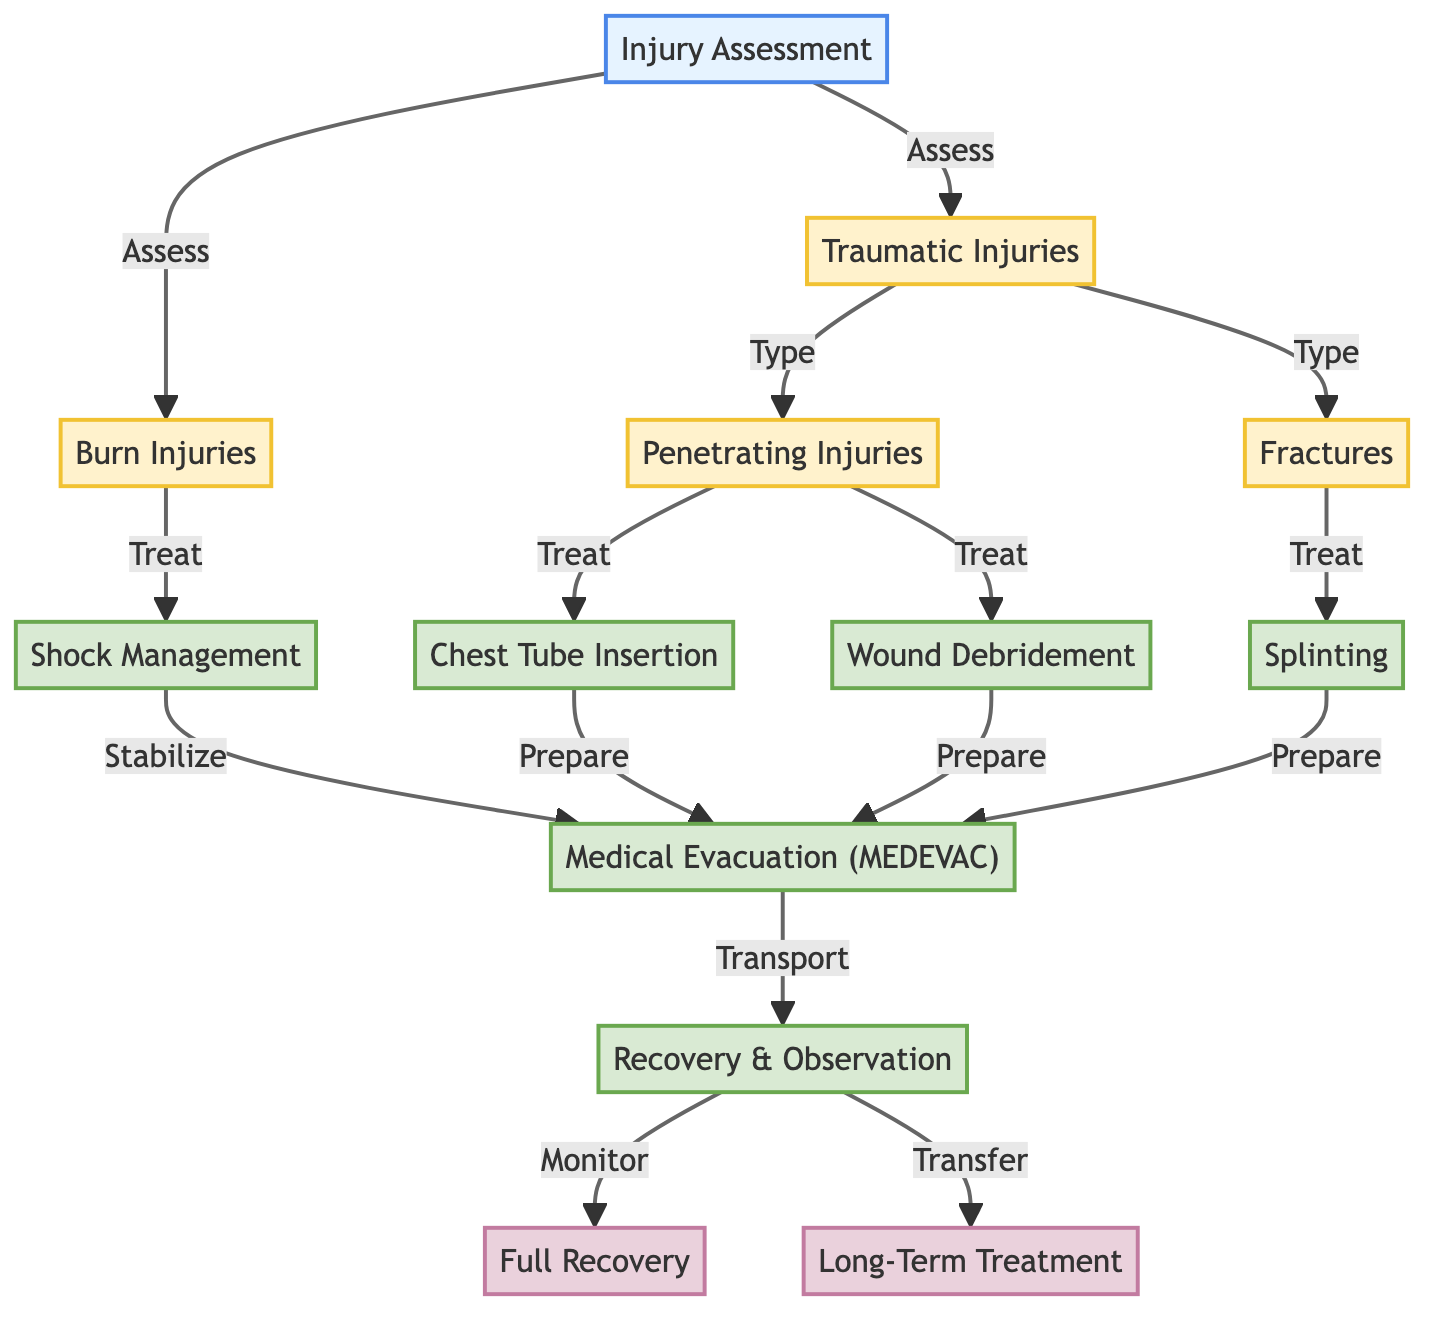What is the first step in the process? The first step in the process is "Injury Assessment," as indicated in the diagram. It is the initial node that starts the flow of assessing various types of injuries.
Answer: Injury Assessment How many types of traumatic injuries are listed? There are two types of traumatic injuries listed: "Penetrating Injuries" and "Fractures." This is determined by looking at the connections branching from the "Traumatic Injuries" node.
Answer: Two What treatment is associated with penetrating injuries? The treatments associated with penetrating injuries are "Chest Tube Insertion" and "Wound Debridement." These treatments are directly linked to the "Penetrating Injuries" node in the flow.
Answer: Chest Tube Insertion, Wound Debridement What type of injury requires shock management? "Burn Injuries" require shock management as shown by the directed edge leading from "Burn Injuries" to "Shock Management" in the diagram.
Answer: Burn Injuries What is the outcome after recovery observation? The outcomes after recovery observation include "Full Recovery" and "Long-Term Treatment." The diagram shows that recovery observation can lead to either of these outcomes as indicated by the outgoing edges.
Answer: Full Recovery, Long-Term Treatment What is the last treatment before medical evacuation? The last treatment before medical evacuation (MEDEVAC) is "Shock Management." It is the treatment that prepares the patient for transport, preceding the MEDEVAC step as indicated in the directional flow.
Answer: Shock Management How does the assessment of traumatic injuries relate to recovery? The assessment of traumatic injuries leads to determining the treatment needed, which ultimately influences whether the patient will achieve full recovery or require long-term treatment. This is observed in the flow, where treatment options stem from injury types and subsequently proceed to recovery outcomes.
Answer: Through treatment determination Which step comes after chest tube insertion? The step that comes after chest tube insertion is "Medical Evacuation (MEDEVAC)." This connection is established since chest tube insertion prepares the patient for the MEDEVAC process.
Answer: Medical Evacuation (MEDEVAC) What defines the treatment for fractures? The treatment for fractures is defined as "Splinting." This is indicated by the direct link from the "Fractures" node leading to the treatment node within the diagram.
Answer: Splinting 